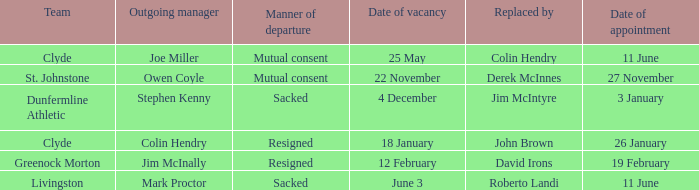Identify the mode of departure for the appointment on january 2 Resigned. 